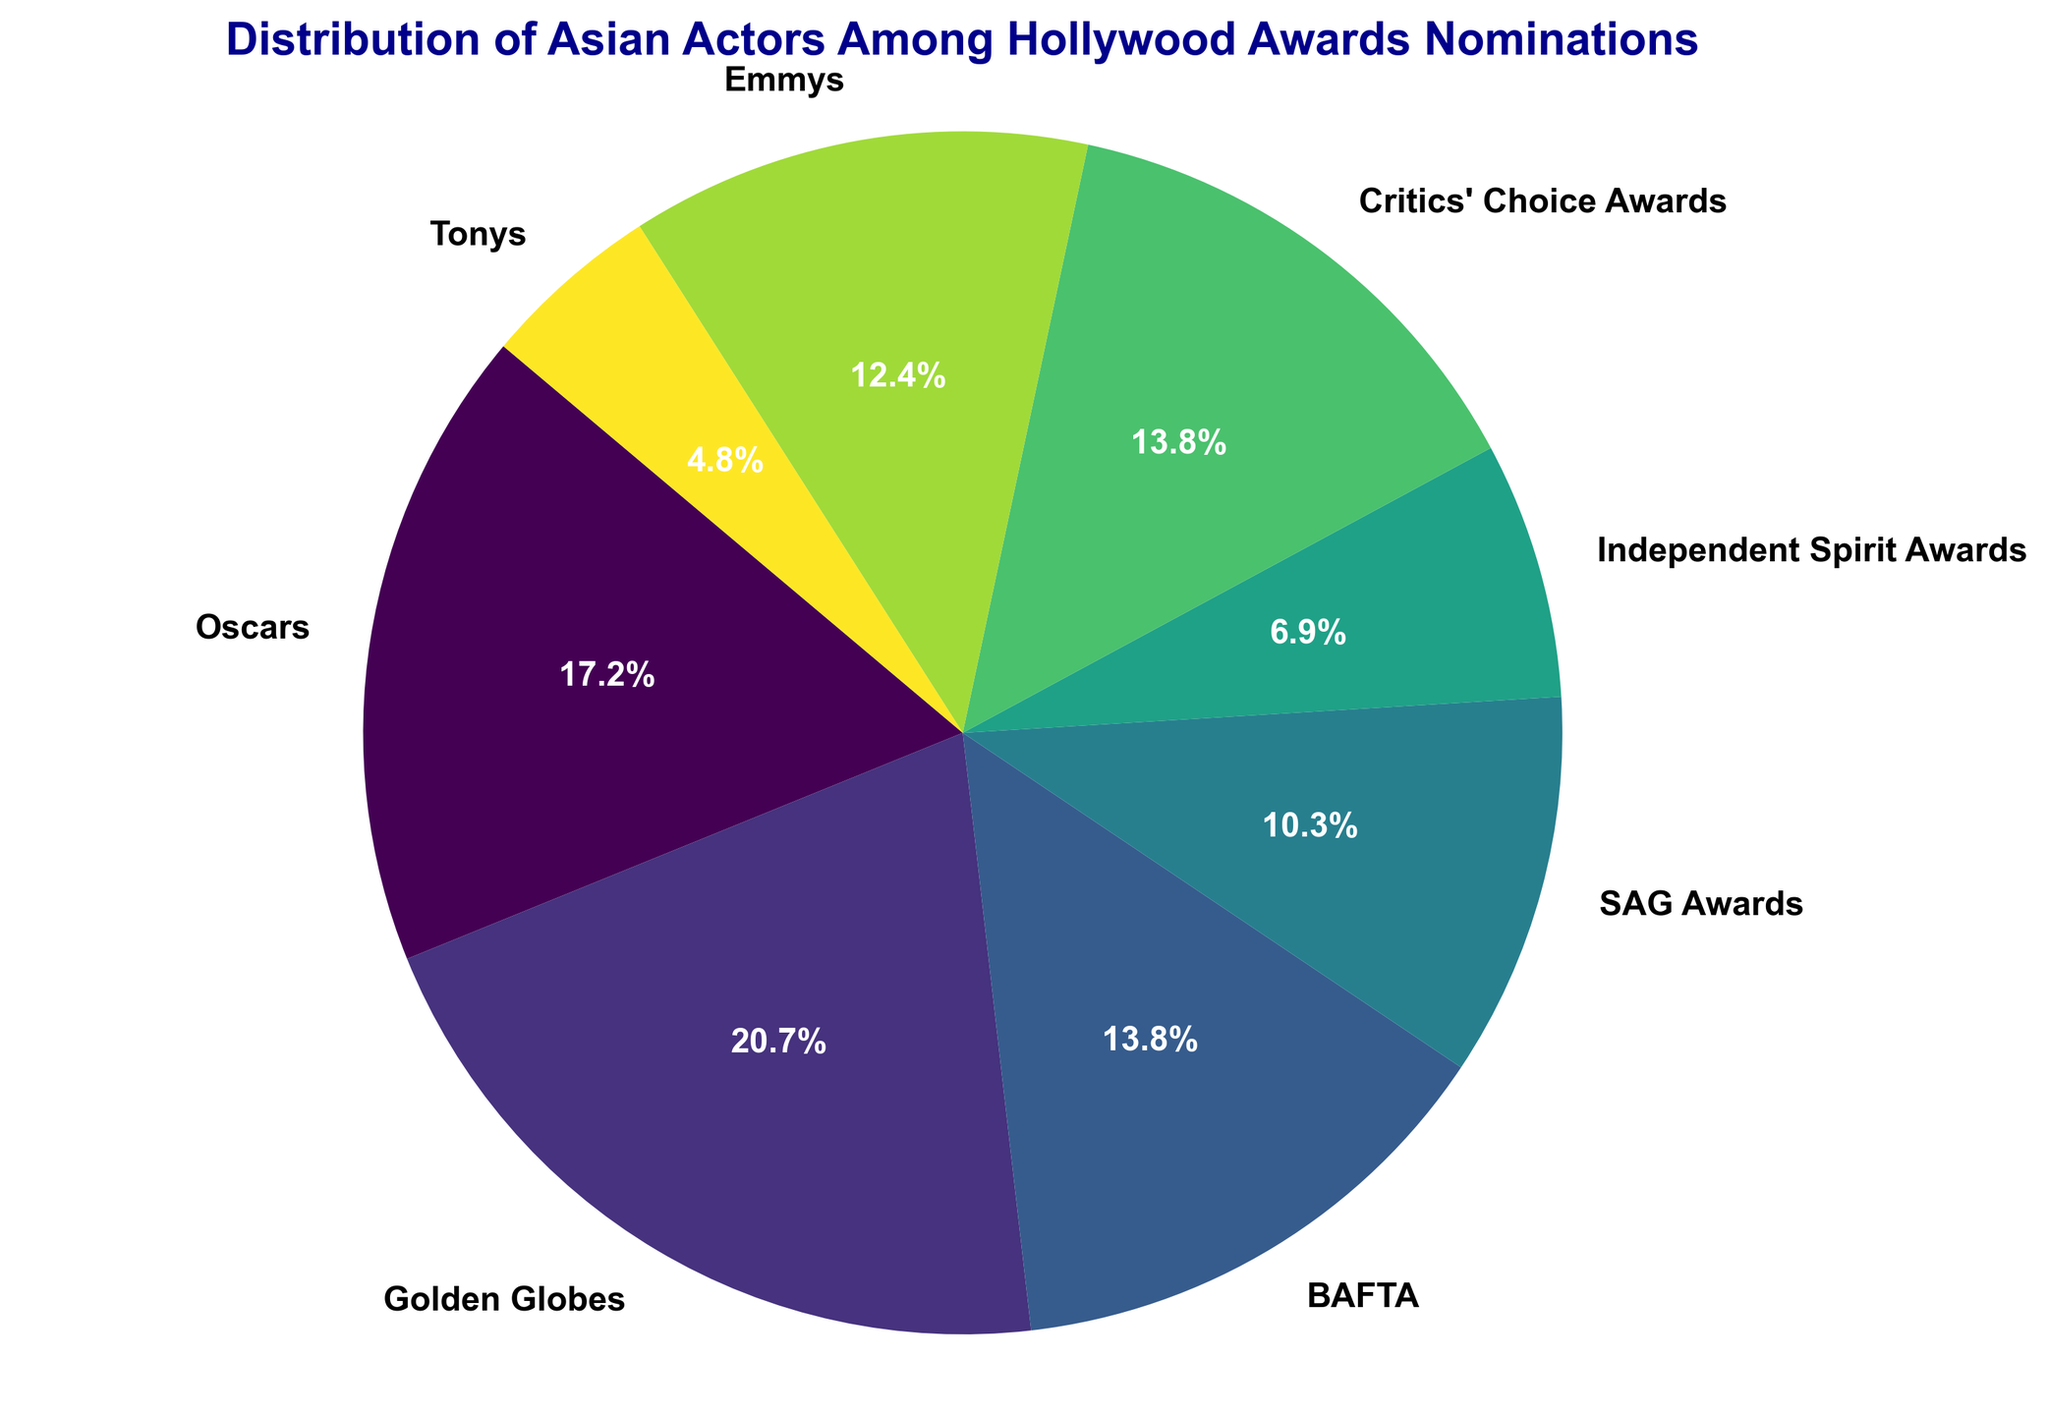what proportion of nominations do the Oscars and Golden Globes combined represent? First, identify the number of nominations for the Oscars (25) and the Golden Globes (30). Then add these two values to get the combined nominations of 55. Sum up the total nominations across all awards, which is 155. Calculate the proportion by dividing the combined nominations by the total nominations: 55/155 = 0.3548, which is approximately 35.5%.
Answer: 35.5% Which award has the fewest nominations? Look at the pie chart and identify the segment with the smallest area. The Tonys, with 7 nominations, have the smallest segment in the chart.
Answer: Tonys Are the nominations for the BAFTA and Critics' Choice Awards equal? Compare the size of the pie chart segments for BAFTA and Critics' Choice Awards. The BAFTA and Critics' Choice Awards both have 20 nominations each.
Answer: Yes What is the ratio of SAG Awards nominations to Independent Spirit Awards nominations? Look at the pie chart to find the number of nominations for SAG Awards (15) and Independent Spirit Awards (10). Calculate the ratio by dividing the SAG Awards nominations by the Independent Spirit Awards nominations: 15/10 = 1.5.
Answer: 1.5 Which award has more nominations: Emmys or Independent Spirit Awards? Compare the size of the pie chart segments representing the Emmys and Independent Spirit Awards. The Emmys have 18 nominations, while the Independent Spirit Awards have 10 nominations. Emmys have more nominations.
Answer: Emmys What is the total number of nominations for the Critics' Choice Awards and Independent Spirit Awards together? Sum the nominations for the Critics' Choice Awards (20) and Independent Spirit Awards (10): 20 + 10 = 30.
Answer: 30 Which award has a larger number of nominations: BAFTA or SAG Awards? Compare the size of the pie chart segments for BAFTA and SAG Awards. BAFTA has 20 nominations, and SAG Awards have 15 nominations. BAFTA has a larger number of nominations.
Answer: BAFTA Comparing the Golden Globes and Critics' Choice Awards, which one has a higher percentage of nominations? Look at the proportions of both Golden Globes and Critics' Choice Awards. The Golden Globes have 30 nominations, and Critics' Choice Awards have 20 nominations. Calculate their respective percentages: Golden Globes (30/155*100 = 19.35%), Critics' Choice (20/155*100 = 12.90%). Golden Globes have a higher percentage.
Answer: Golden Globes 